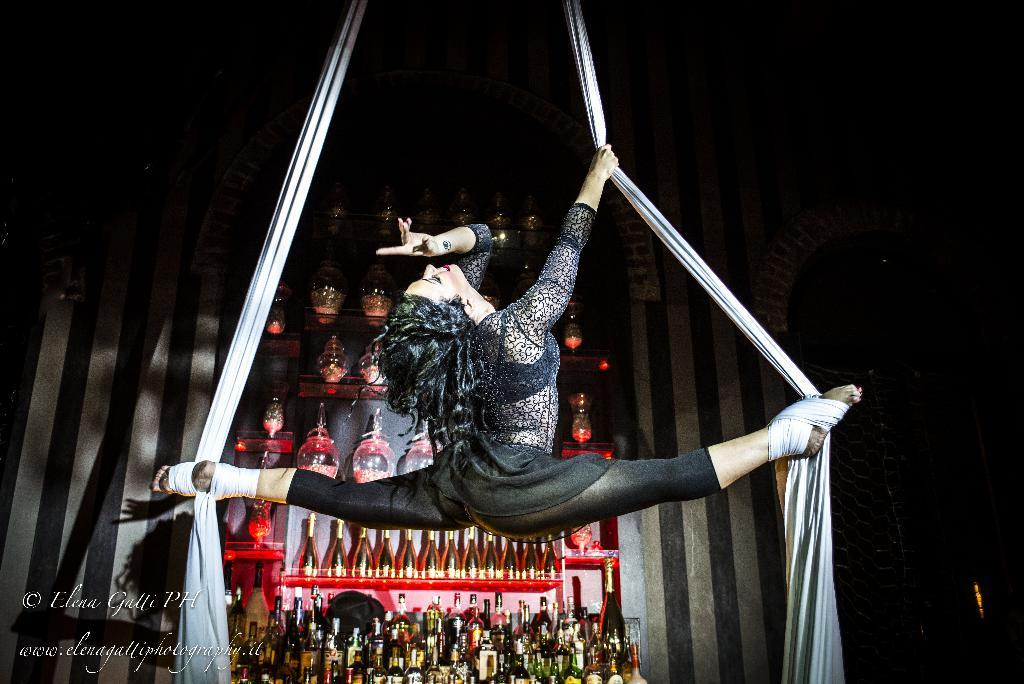What can be seen on the racks in the background of the image? There are alcohol bottles on the racks in the background of the image. What is the main subject of the image? The main subject of the image is a woman. What is the woman doing in the image? The woman is performing aerial silk dance. How many letters are visible on the alcohol bottles in the image? There is no mention of letters on the alcohol bottles in the provided facts, so we cannot determine the number of letters visible. What type of waste can be seen in the image? There is no waste present in the image; it features a woman performing aerial silk dance and alcohol bottles on racks. 